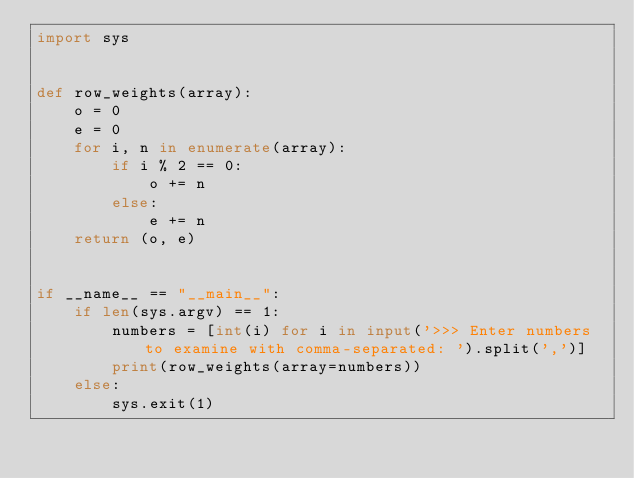<code> <loc_0><loc_0><loc_500><loc_500><_Python_>import sys


def row_weights(array):
    o = 0
    e = 0
    for i, n in enumerate(array):
        if i % 2 == 0:
            o += n
        else:
            e += n
    return (o, e)


if __name__ == "__main__":
    if len(sys.argv) == 1:
        numbers = [int(i) for i in input('>>> Enter numbers to examine with comma-separated: ').split(',')]
        print(row_weights(array=numbers))
    else:
        sys.exit(1)
</code> 